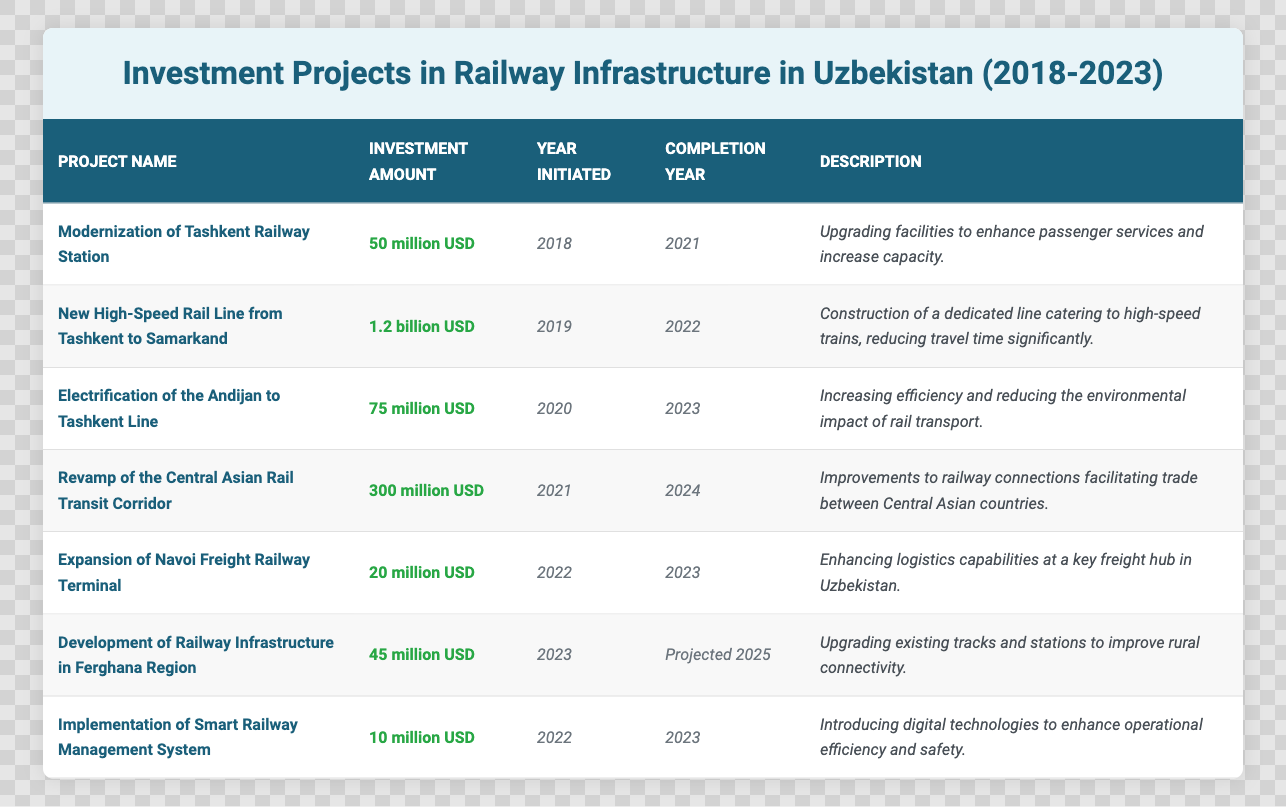What is the total investment amount for the railway projects initiated in 2022? The projects initiated in 2022 are: "Expansion of Navoi Freight Railway Terminal" with 20 million USD and "Implementation of Smart Railway Management System" with 10 million USD. Thus, the total investment amount is 20 + 10 = 30 million USD.
Answer: 30 million USD Which project has the highest investment amount? The project with the highest investment amount is "New High-Speed Rail Line from Tashkent to Samarkand" with 1.2 billion USD.
Answer: 1.2 billion USD What year was the "Electrification of the Andijan to Tashkent Line" project initiated? The "Electrification of the Andijan to Tashkent Line" project was initiated in 2020, as seen in the table.
Answer: 2020 Is the "Development of Railway Infrastructure in Ferghana Region" project set to be completed by 2023? No, the "Development of Railway Infrastructure in Ferghana Region" project is projected to be completed in 2025, not 2023.
Answer: No How many projects were initiated in 2019? There is one project initiated in 2019, which is the "New High-Speed Rail Line from Tashkent to Samarkand."
Answer: 1 What is the average investment amount of the projects completed by 2023? The completed projects by 2023 are: "Modernization of Tashkent Railway Station" (50 million USD), "New High-Speed Rail Line" (1.2 billion USD), "Electrification of the Andijan to Tashkent Line" (75 million USD), "Expansion of Navoi Freight Railway Terminal" (20 million USD), and "Implementation of Smart Railway Management System" (10 million USD). Adding these amounts gives 50 + 1200 + 75 + 20 + 10 = 1355 million USD. Dividing by the number of projects (5) gives an average of 1355 / 5 = 271 million USD.
Answer: 271 million USD What is the completion status of the project "Revamp of the Central Asian Rail Transit Corridor"? The project "Revamp of the Central Asian Rail Transit Corridor" is expected to be completed in 2024, as indicated in the completion year.
Answer: 2024 Which two projects were initiated in the same year? The projects "Expansion of Navoi Freight Railway Terminal" and "Implementation of Smart Railway Management System" were both initiated in 2022, as per the table.
Answer: 2 projects What is the total investment amount for projects initiated in 2020 and 2022? The project "Electrification of the Andijan to Tashkent Line" was initiated in 2020 with 75 million USD, and the two projects from 2022 together total 30 million USD. Adding them together gives 75 + 30 = 105 million USD.
Answer: 105 million USD Which project aims to enhance logistics capabilities? The project "Expansion of Navoi Freight Railway Terminal" aims to enhance logistics capabilities at a freight hub.
Answer: Expansion of Navoi Freight Railway Terminal 